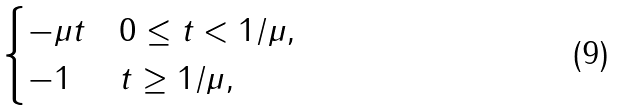<formula> <loc_0><loc_0><loc_500><loc_500>\begin{cases} - \mu t & 0 \leq t < 1 / \mu , \\ - 1 & t \geq 1 / \mu , \end{cases}</formula> 